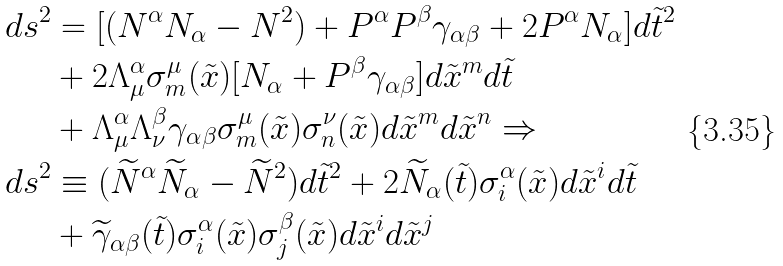<formula> <loc_0><loc_0><loc_500><loc_500>d s ^ { 2 } & = [ ( N ^ { \alpha } N _ { \alpha } - N ^ { 2 } ) + P ^ { \alpha } P ^ { \beta } \gamma _ { \alpha \beta } + 2 P ^ { \alpha } N _ { \alpha } ] d \tilde { t } ^ { 2 } \\ & + 2 \Lambda ^ { \alpha } _ { \mu } \sigma ^ { \mu } _ { m } ( \tilde { x } ) [ N _ { \alpha } + P ^ { \beta } \gamma _ { \alpha \beta } ] d \tilde { x } ^ { m } d \tilde { t } \\ & + \Lambda ^ { \alpha } _ { \mu } \Lambda ^ { \beta } _ { \nu } \gamma _ { \alpha \beta } \sigma ^ { \mu } _ { m } ( \tilde { x } ) \sigma ^ { \nu } _ { n } ( \tilde { x } ) d \tilde { x } ^ { m } d \tilde { x } ^ { n } \Rightarrow \\ d s ^ { 2 } & \equiv ( \widetilde { N } ^ { \alpha } \widetilde { N } _ { \alpha } - \widetilde { N } ^ { 2 } ) d \tilde { t } ^ { 2 } + 2 \widetilde { N } _ { \alpha } ( \tilde { t } ) \sigma ^ { \alpha } _ { i } ( \tilde { x } ) d \tilde { x } ^ { i } d \tilde { t } \\ & + \widetilde { \gamma } _ { \alpha \beta } ( \tilde { t } ) \sigma ^ { \alpha } _ { i } ( \tilde { x } ) \sigma ^ { \beta } _ { j } ( \tilde { x } ) d \tilde { x } ^ { i } d \tilde { x } ^ { j }</formula> 